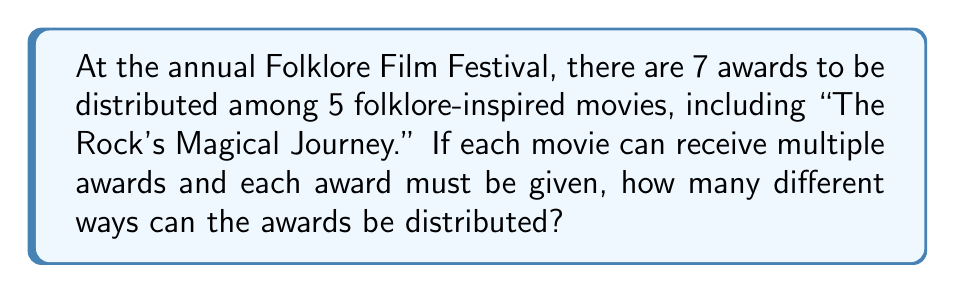Provide a solution to this math problem. Let's approach this step-by-step:

1) This is a problem of distributing distinct objects (awards) into non-distinct containers (movies).

2) Each award has 5 choices (can go to any of the 5 movies), and this choice is independent of where the other awards go.

3) This scenario can be modeled using the multiplication principle.

4) For each award:
   - The first award has 5 choices
   - The second award has 5 choices
   - ...
   - The seventh award has 5 choices

5) Therefore, the total number of ways to distribute the awards is:

   $$ 5 \times 5 \times 5 \times 5 \times 5 \times 5 \times 5 $$

6) This can be written as an exponent:

   $$ 5^7 $$

7) Calculate:
   $$ 5^7 = 5 \times 5 \times 5 \times 5 \times 5 \times 5 \times 5 = 78,125 $$

Thus, there are 78,125 different ways to distribute the awards.
Answer: $5^7 = 78,125$ 